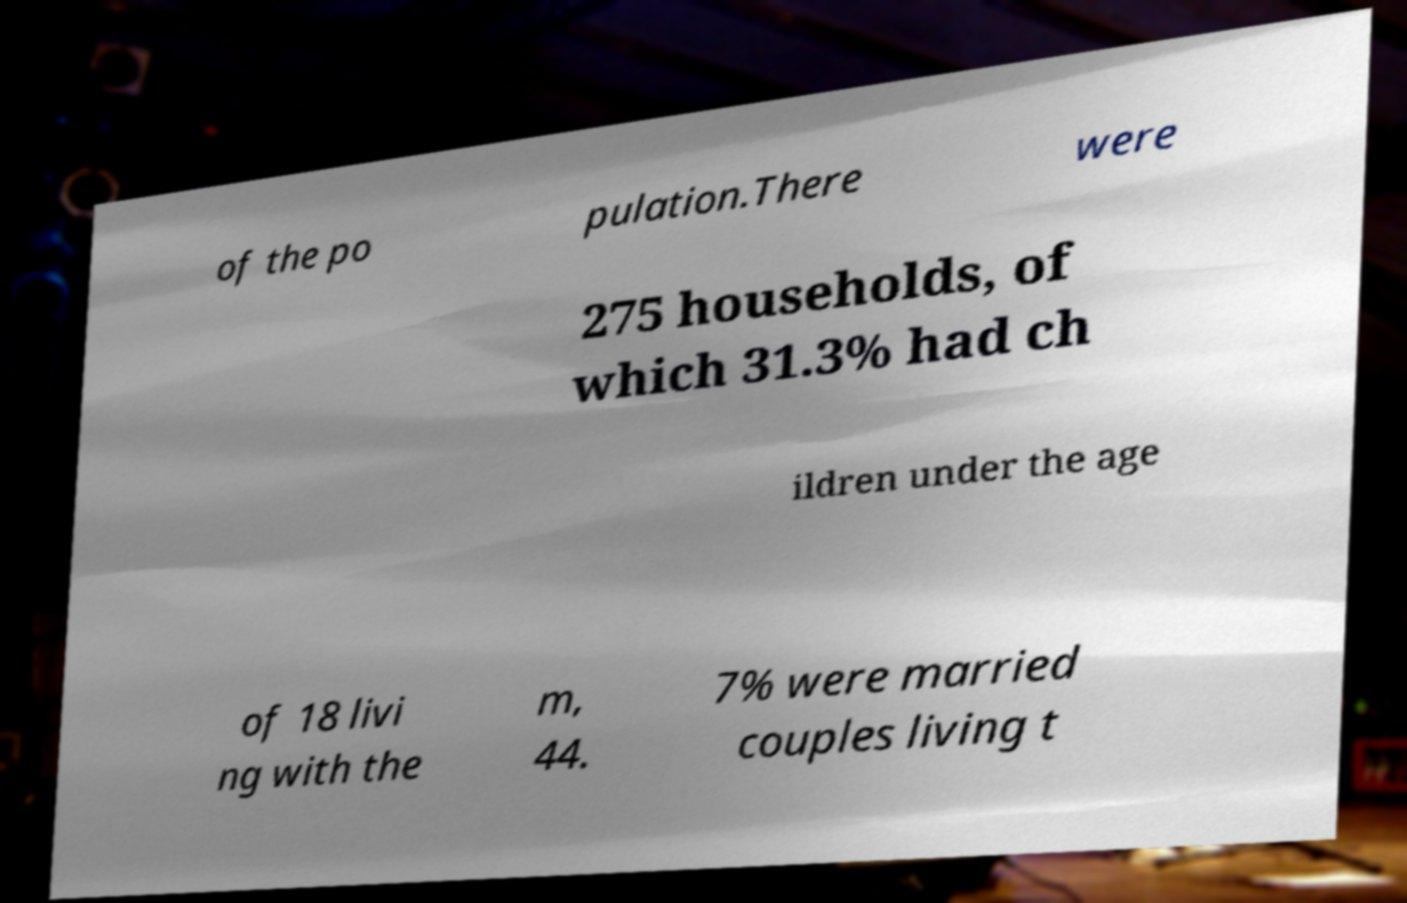Can you read and provide the text displayed in the image?This photo seems to have some interesting text. Can you extract and type it out for me? of the po pulation.There were 275 households, of which 31.3% had ch ildren under the age of 18 livi ng with the m, 44. 7% were married couples living t 